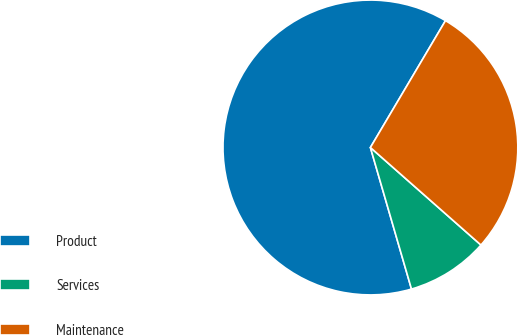Convert chart. <chart><loc_0><loc_0><loc_500><loc_500><pie_chart><fcel>Product<fcel>Services<fcel>Maintenance<nl><fcel>63.0%<fcel>9.0%<fcel>28.0%<nl></chart> 